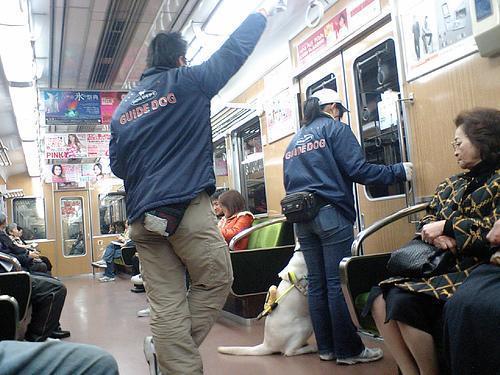How many people can be seen?
Give a very brief answer. 4. How many benches are there?
Give a very brief answer. 2. How many arched windows are there to the left of the clock tower?
Give a very brief answer. 0. 